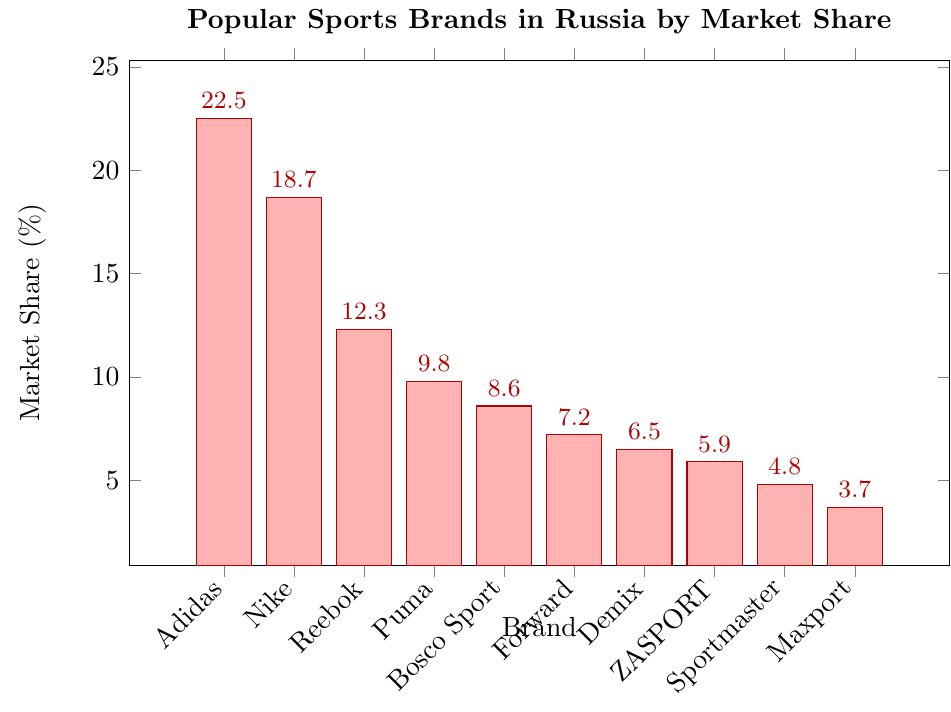Which brand has the highest market share? The highest market share is the tallest bar in the chart. By observing the bars, the tallest belongs to Adidas.
Answer: Adidas How much more market share does Adidas have compared to Reebok? Find the market shares of Adidas and Reebok from the chart: Adidas (22.5%), Reebok (12.3%). Subtract Reebok's share from Adidas's share: 22.5 - 12.3 = 10.2.
Answer: 10.2 What is the total market share of Nike and Puma combined? Add the market shares of Nike (18.7%) and Puma (9.8%) from the chart to get the combined share: 18.7 + 9.8 = 28.5.
Answer: 28.5 Which brand has a market share closest to 10%? Locate the bars around the 10% mark and find the brand with a market share close to it. Puma has a market share of 9.8%, which is the closest to 10%.
Answer: Puma How many brands have a market share greater than 15%? Identify the brands whose bars exceed the 15% mark. Adidas (22.5%) and Nike (18.7%) are the only ones. Count these brands: 2.
Answer: 2 What is the difference in market share between Forward and ZASPORT? From the chart, Forward has a market share of 7.2% and ZASPORT has 5.9%. Subtract ZASPORT's share from Forward's: 7.2 - 5.9 = 1.3.
Answer: 1.3 Which brands have market shares that are less than 6%? Identify the bars below the 6% mark. Demix (6.5%) is just above, so ZASPORT (5.9%), Sportmaster (4.8%), and Maxport (3.7%) qualify.
Answer: ZASPORT, Sportmaster, Maxport What is the average market share of the top three brands? Determine the top three brands by market share: Adidas (22.5%), Nike (18.7%), Reebok (12.3%). Calculate the average: (22.5 + 18.7 + 12.3) / 3 = 17.83.
Answer: 17.83 How much market share does Bosco Sport have relative to the total of Forward and Demix? From the chart, Bosco Sport has 8.6%, Forward has 7.2%, and Demix has 6.5%. First, find the total of Forward and Demix: 7.2 + 6.5 = 13.7. Then divide Bosco Sport's share by this total: 8.6 / 13.7 ≈ 0.628.
Answer: 0.628 Are there more brands with market shares above 10% or below 10%? Identify brands above 10%: Adidas (22.5%), Nike (18.7%), Reebok (12.3%)—total 3. Brands below 10%: Puma (9.8%), Bosco Sport (8.6%), Forward (7.2%), Demix (6.5%), ZASPORT (5.9%), Sportmaster (4.8%), Maxport (3.7%)—total 7. Compare the counts: 3 vs 7.
Answer: below 10% 